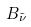Convert formula to latex. <formula><loc_0><loc_0><loc_500><loc_500>B _ { \tilde { \nu } }</formula> 